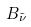Convert formula to latex. <formula><loc_0><loc_0><loc_500><loc_500>B _ { \tilde { \nu } }</formula> 